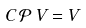Convert formula to latex. <formula><loc_0><loc_0><loc_500><loc_500>C \, \mathcal { P } \, V = V</formula> 